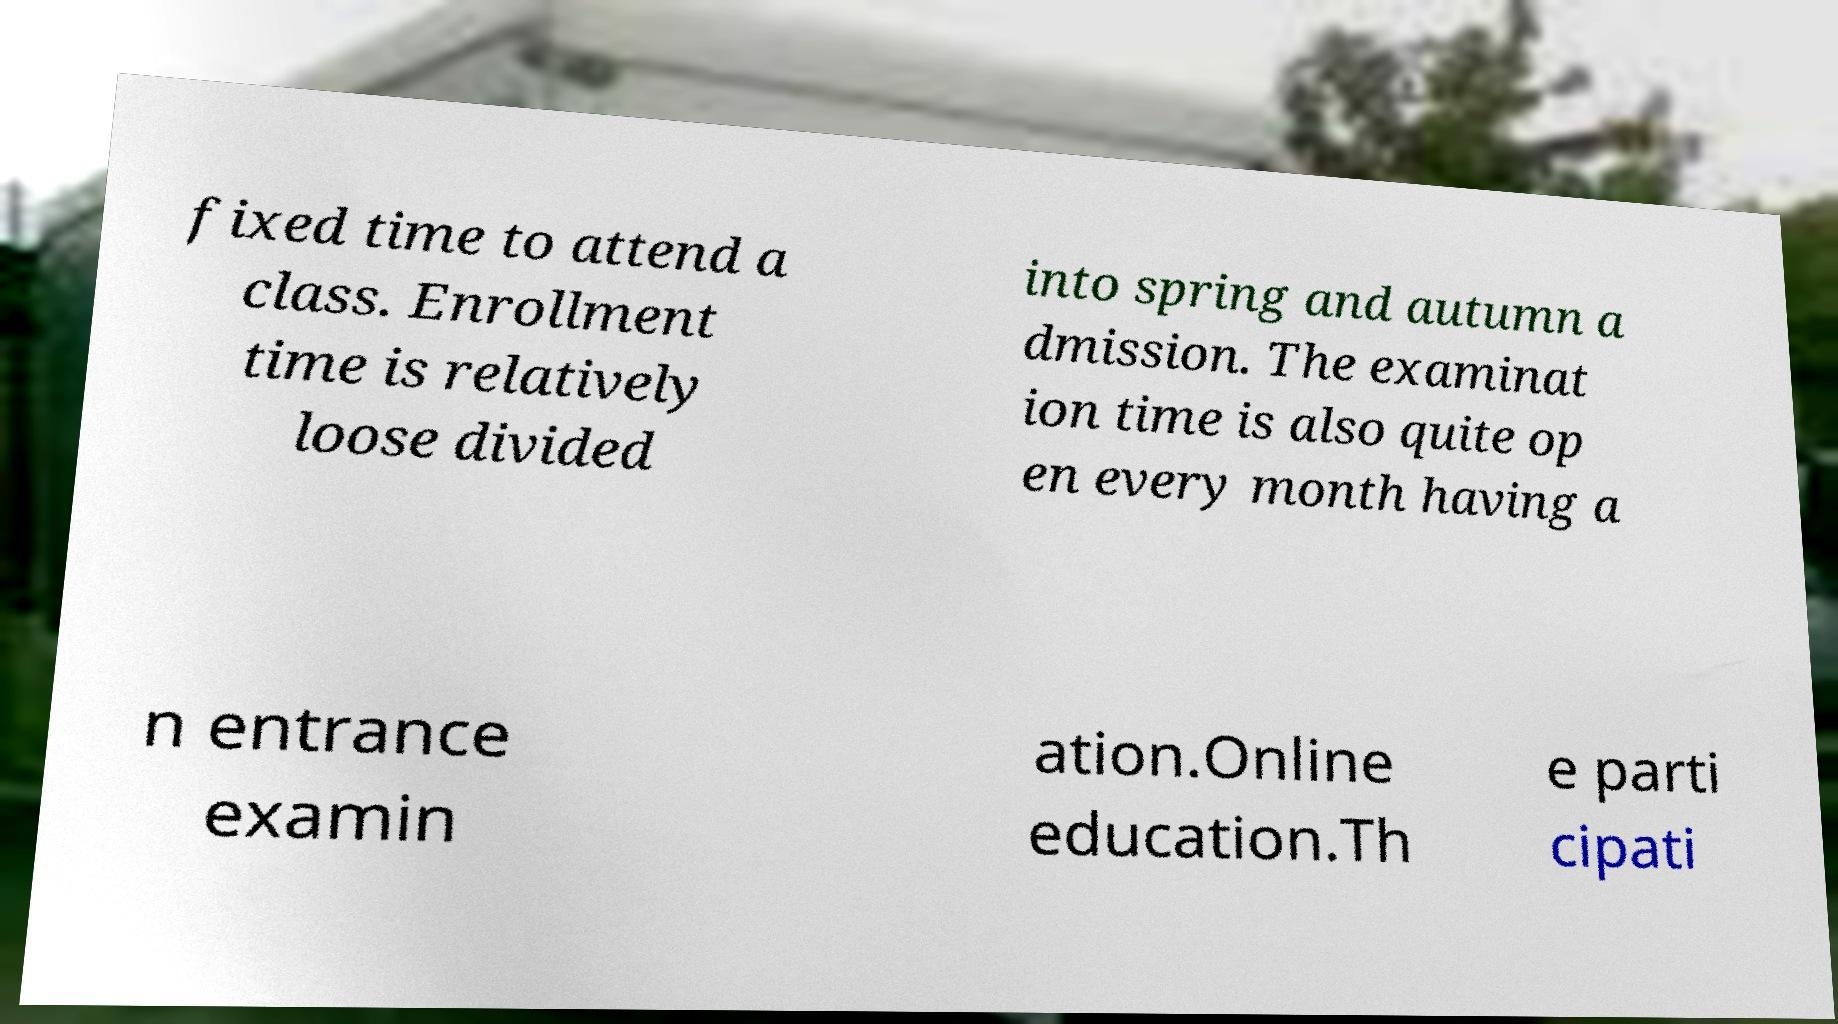For documentation purposes, I need the text within this image transcribed. Could you provide that? fixed time to attend a class. Enrollment time is relatively loose divided into spring and autumn a dmission. The examinat ion time is also quite op en every month having a n entrance examin ation.Online education.Th e parti cipati 